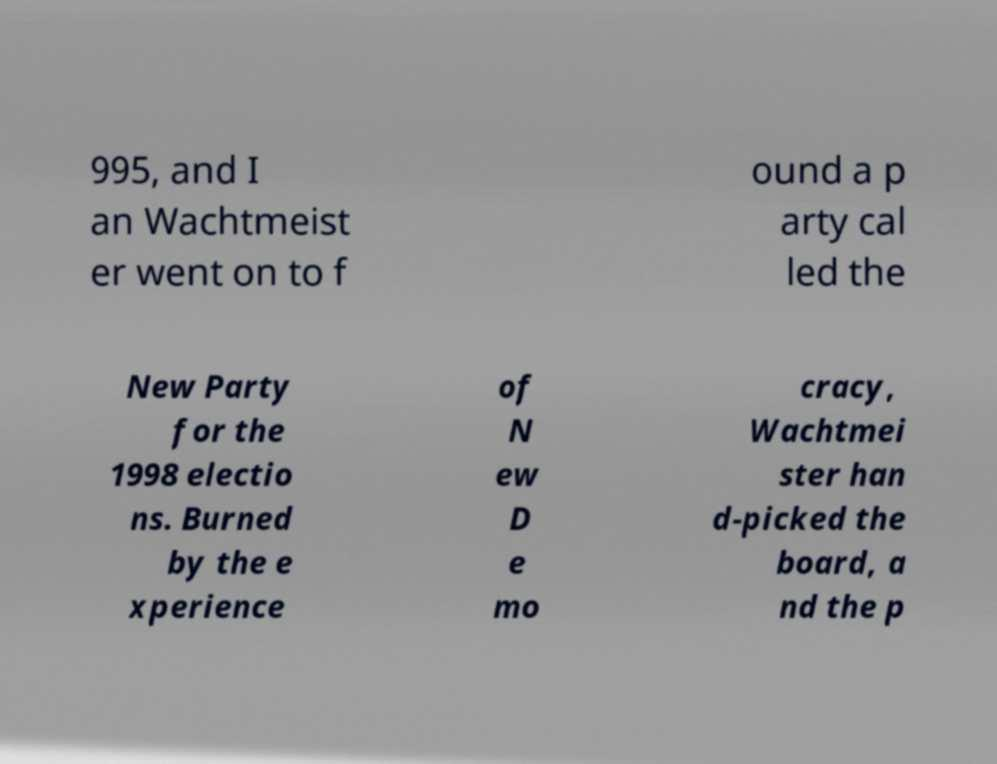What messages or text are displayed in this image? I need them in a readable, typed format. 995, and I an Wachtmeist er went on to f ound a p arty cal led the New Party for the 1998 electio ns. Burned by the e xperience of N ew D e mo cracy, Wachtmei ster han d-picked the board, a nd the p 